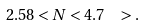<formula> <loc_0><loc_0><loc_500><loc_500>2 . 5 8 < N < 4 . 7 \ \ > .</formula> 